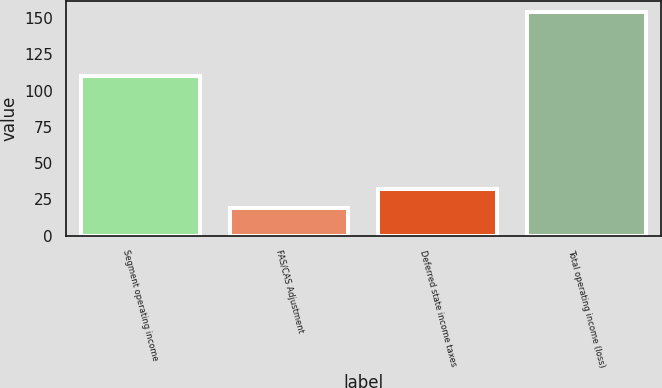Convert chart to OTSL. <chart><loc_0><loc_0><loc_500><loc_500><bar_chart><fcel>Segment operating income<fcel>FAS/CAS Adjustment<fcel>Deferred state income taxes<fcel>Total operating income (loss)<nl><fcel>110<fcel>19<fcel>32.5<fcel>154<nl></chart> 